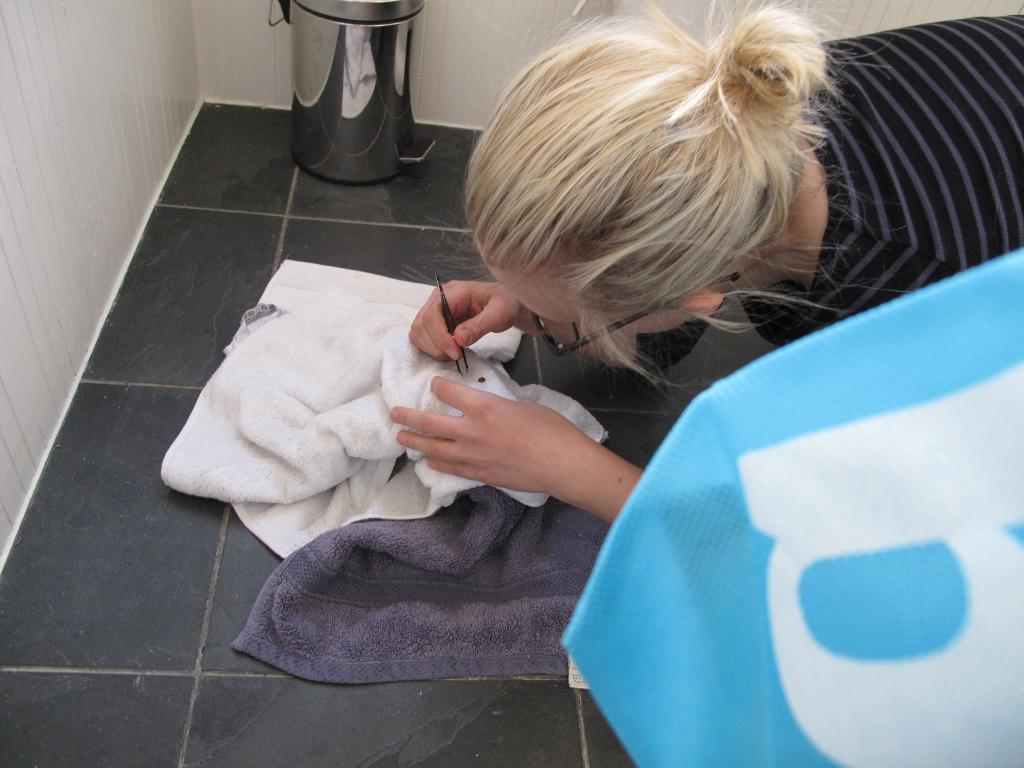<image>
Relay a brief, clear account of the picture shown. A woman is using tweezers on a towel near a bag with a B. 